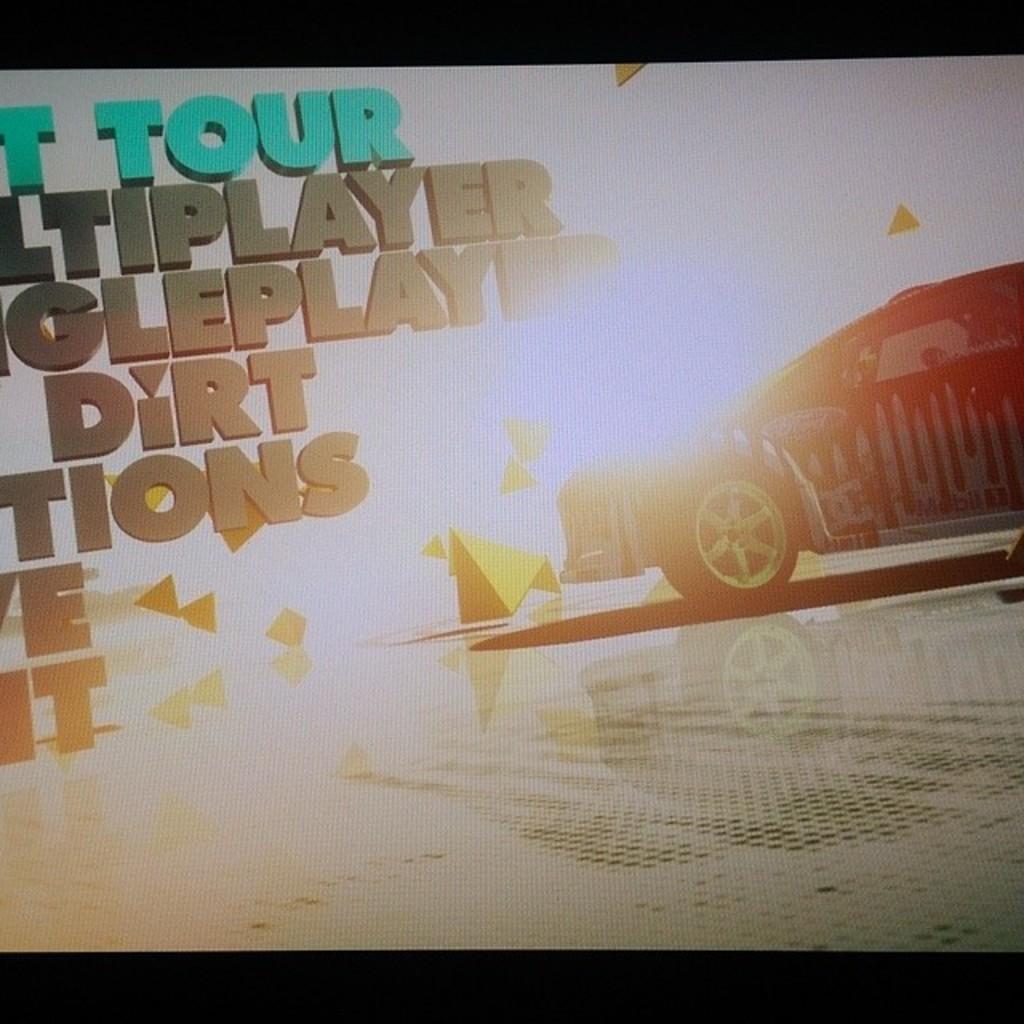Please provide a concise description of this image. In the center of the image we can see a screen. On the screen, we can see a car, some text and a few other objects. And we can see the black colored border at the top and bottom of the image. 